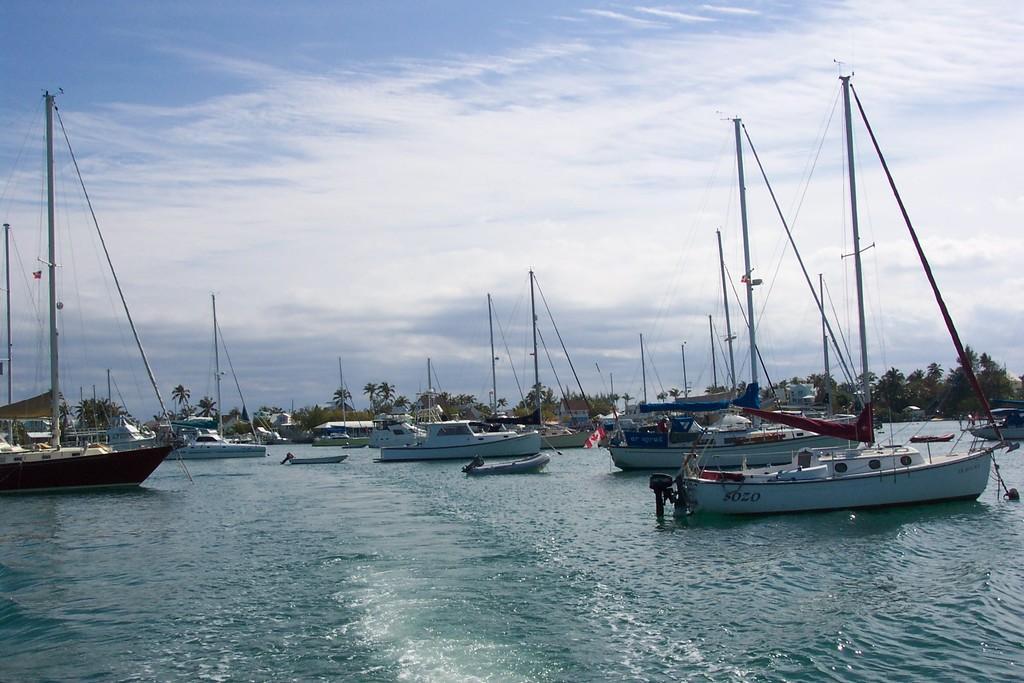Can you describe this image briefly? In this picture we can observe a fleet on the water. In the background there are trees. We can observe poles. There is a sky with some clouds. 